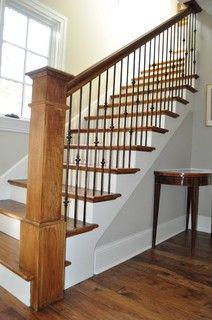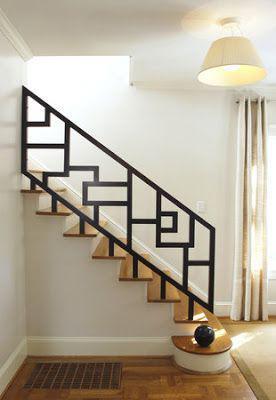The first image is the image on the left, the second image is the image on the right. Analyze the images presented: Is the assertion "At least one image was taken from upstairs." valid? Answer yes or no. No. The first image is the image on the left, the second image is the image on the right. Evaluate the accuracy of this statement regarding the images: "The left image shows a staircase that ascends rightward without turning and has an enclosed side and baseboards, a brown wood handrail, and vertical metal bars.". Is it true? Answer yes or no. Yes. 